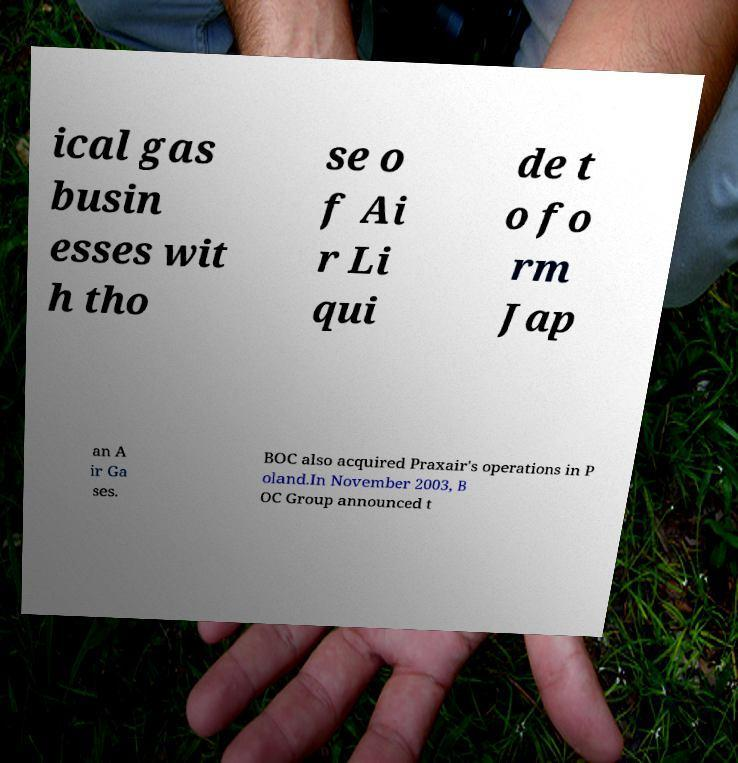Please identify and transcribe the text found in this image. ical gas busin esses wit h tho se o f Ai r Li qui de t o fo rm Jap an A ir Ga ses. BOC also acquired Praxair's operations in P oland.In November 2003, B OC Group announced t 